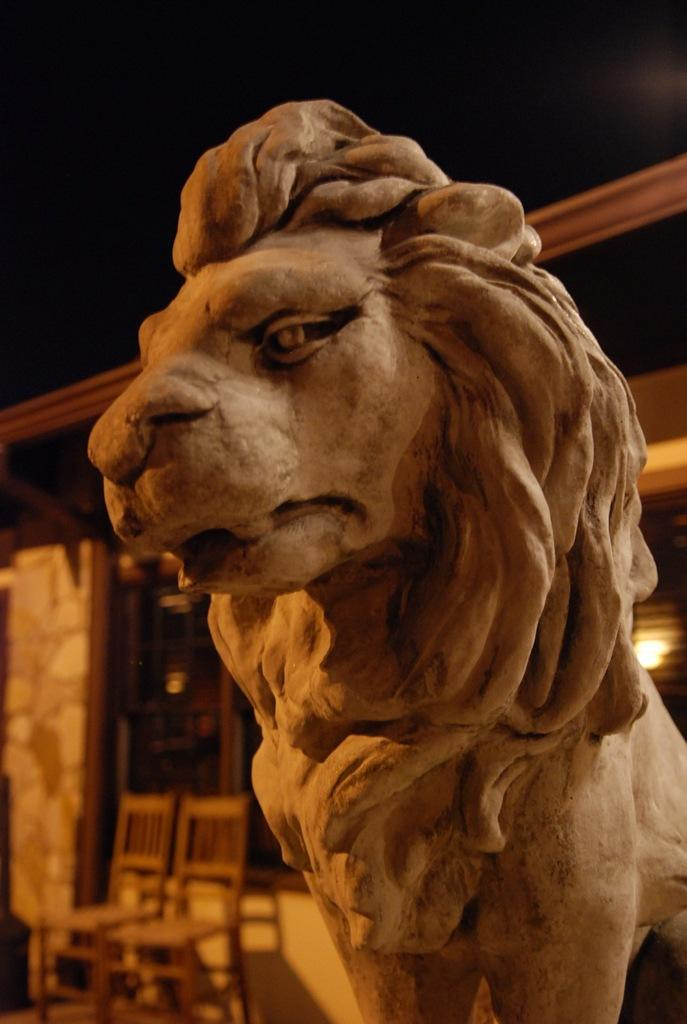What type of statue is present in the image? There is a statue of a lion made of rock in the image. What furniture can be seen on the left side of the image? There are two chairs on the left side of the image. What type of structure is visible in the background of the image? There is a small house in the background of the image. What is visible at the top of the image? The sky is visible at the top of the image. What type of oil is being used to maintain the lion statue in the image? There is no mention of oil being used to maintain the lion statue in the image. How many pies are present on the chairs in the image? There is no mention of pies in the image; the chairs are empty. 